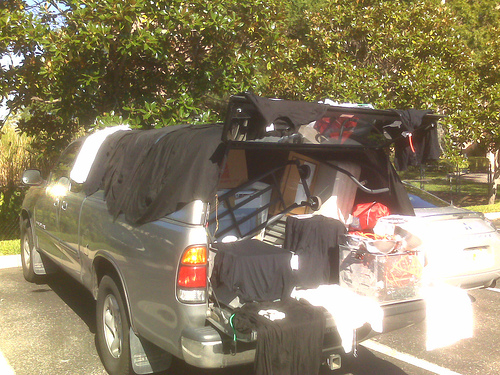<image>
Is the car behind the bag? No. The car is not behind the bag. From this viewpoint, the car appears to be positioned elsewhere in the scene. 